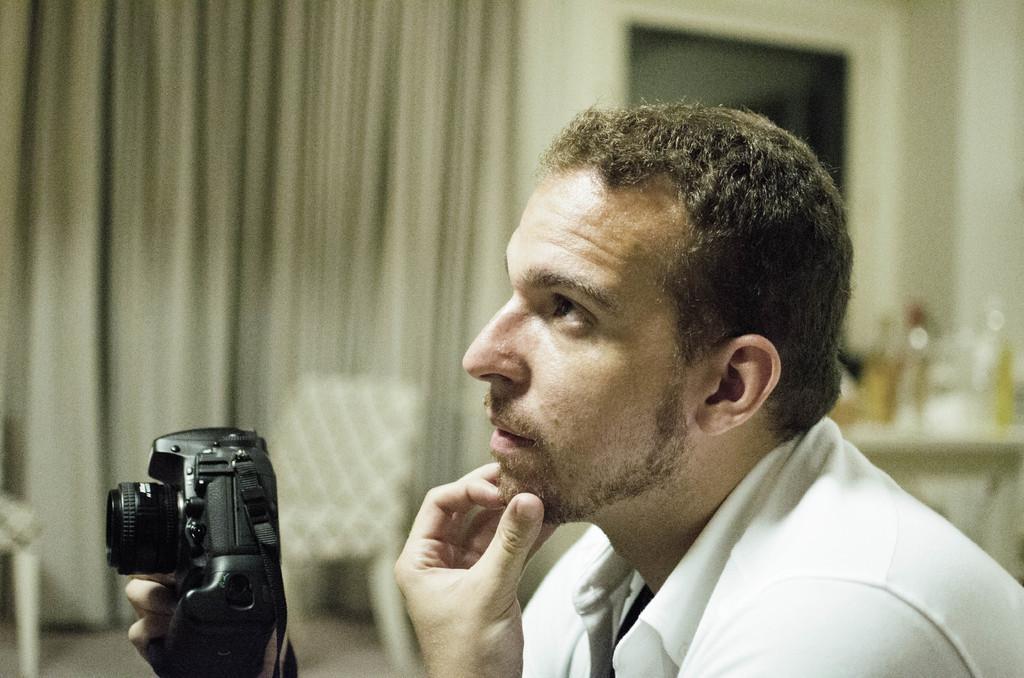Describe this image in one or two sentences. In this image i can see a person wearing a white shirt and holding a camera in his hands. In the background i can see curtains, chairs and a table. 